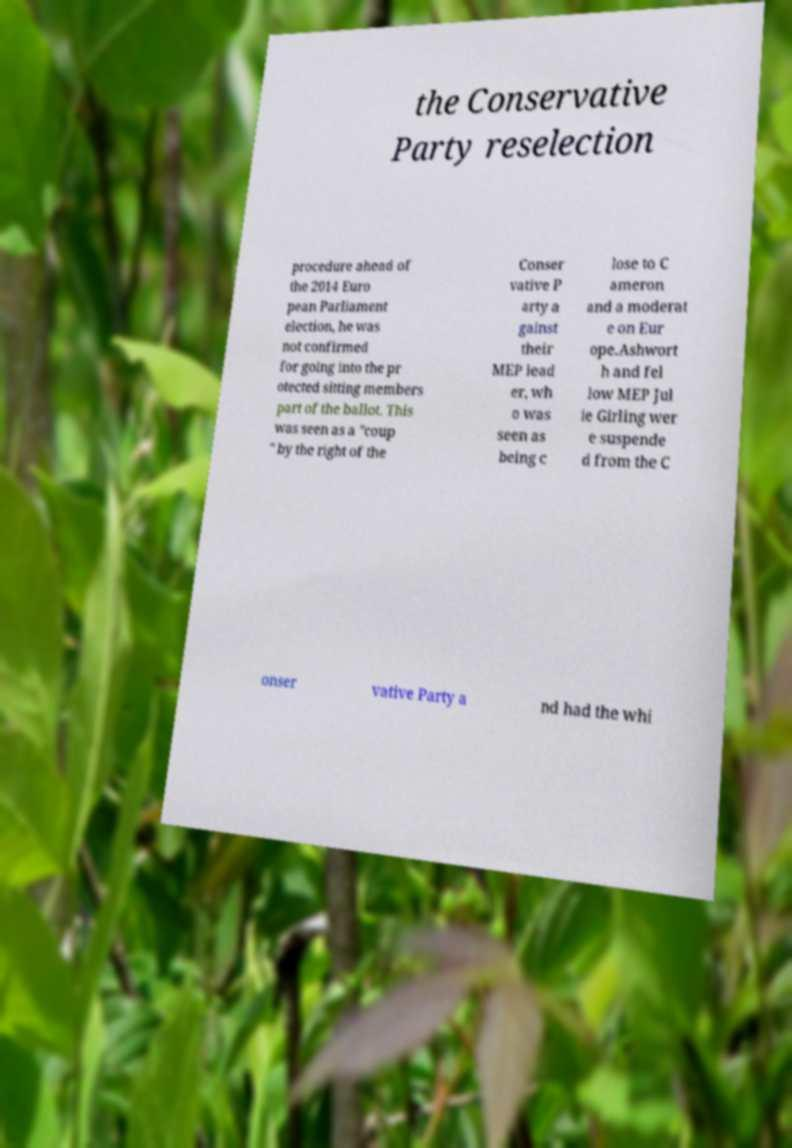I need the written content from this picture converted into text. Can you do that? the Conservative Party reselection procedure ahead of the 2014 Euro pean Parliament election, he was not confirmed for going into the pr otected sitting members part of the ballot. This was seen as a "coup " by the right of the Conser vative P arty a gainst their MEP lead er, wh o was seen as being c lose to C ameron and a moderat e on Eur ope.Ashwort h and fel low MEP Jul ie Girling wer e suspende d from the C onser vative Party a nd had the whi 